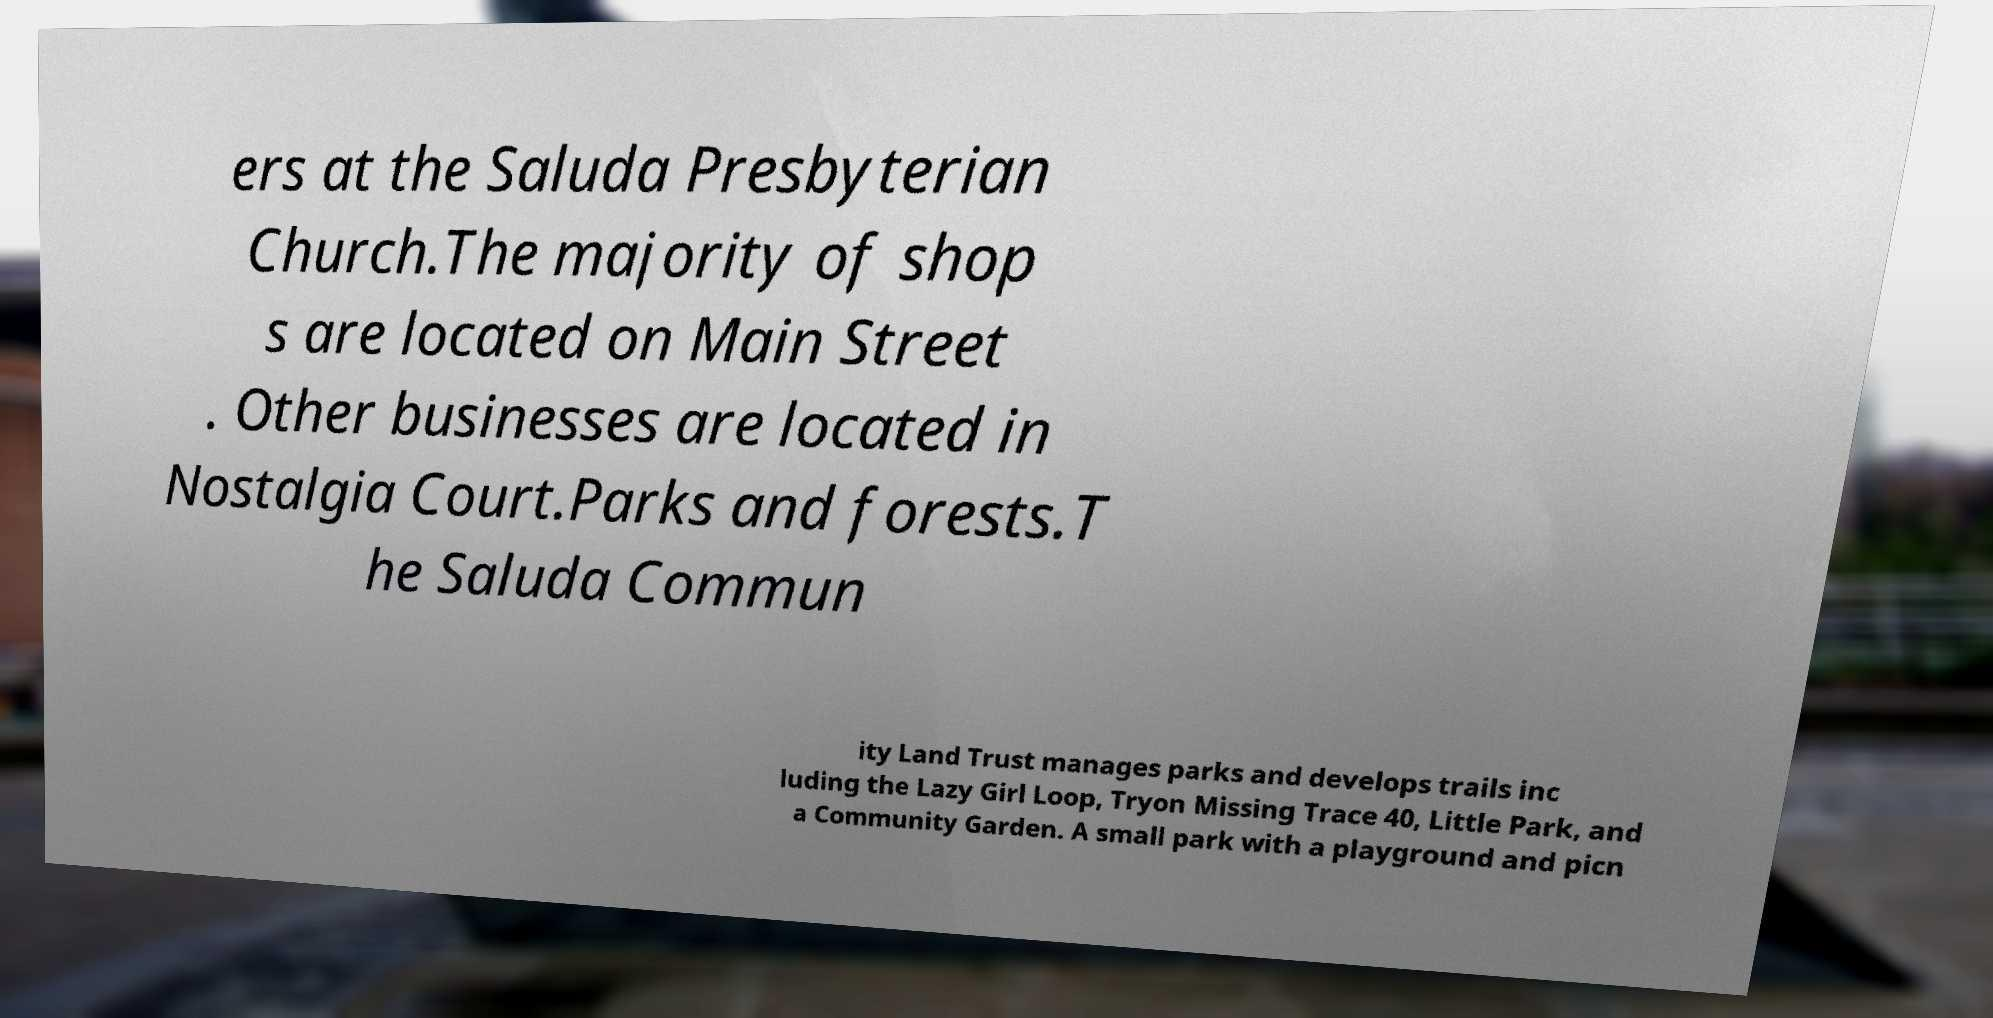Please read and relay the text visible in this image. What does it say? ers at the Saluda Presbyterian Church.The majority of shop s are located on Main Street . Other businesses are located in Nostalgia Court.Parks and forests.T he Saluda Commun ity Land Trust manages parks and develops trails inc luding the Lazy Girl Loop, Tryon Missing Trace 40, Little Park, and a Community Garden. A small park with a playground and picn 